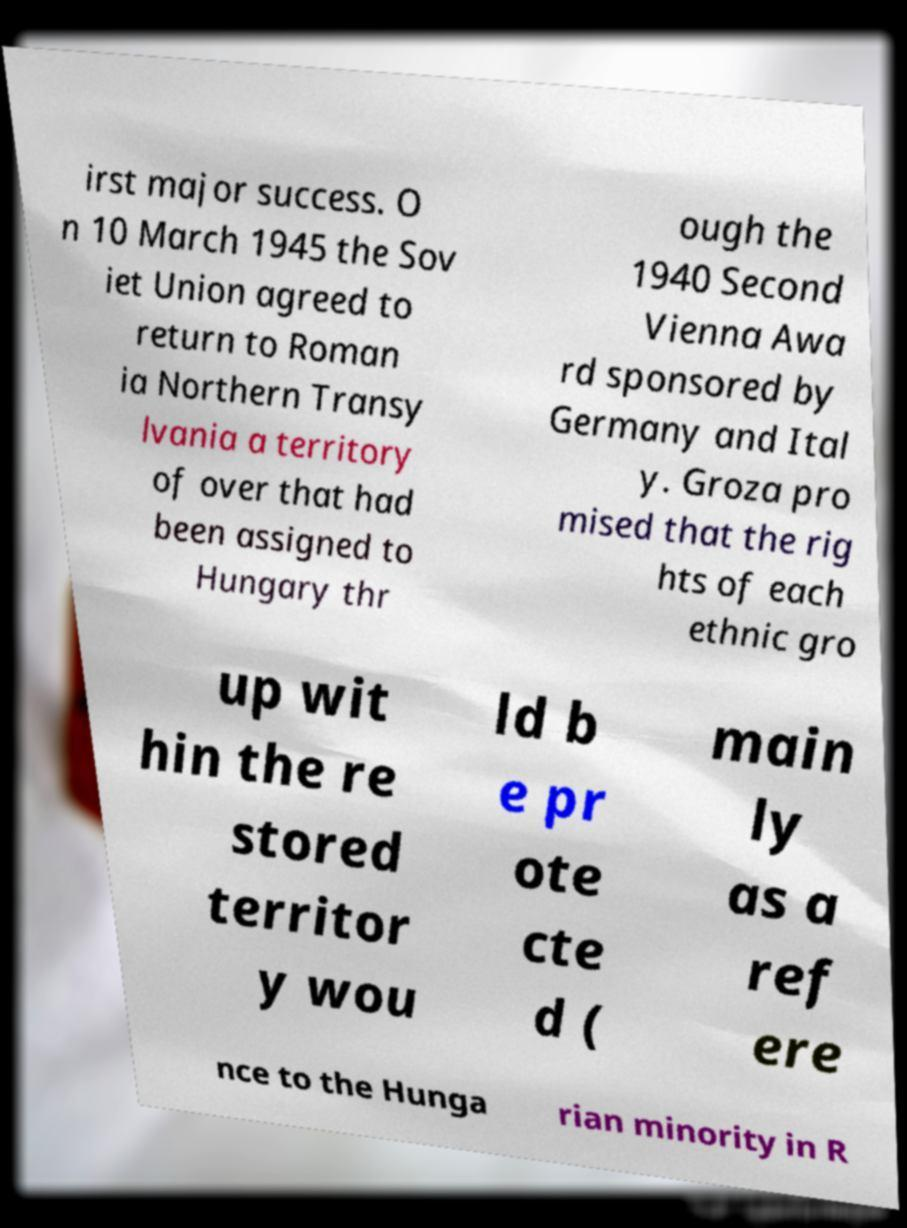Could you assist in decoding the text presented in this image and type it out clearly? irst major success. O n 10 March 1945 the Sov iet Union agreed to return to Roman ia Northern Transy lvania a territory of over that had been assigned to Hungary thr ough the 1940 Second Vienna Awa rd sponsored by Germany and Ital y. Groza pro mised that the rig hts of each ethnic gro up wit hin the re stored territor y wou ld b e pr ote cte d ( main ly as a ref ere nce to the Hunga rian minority in R 